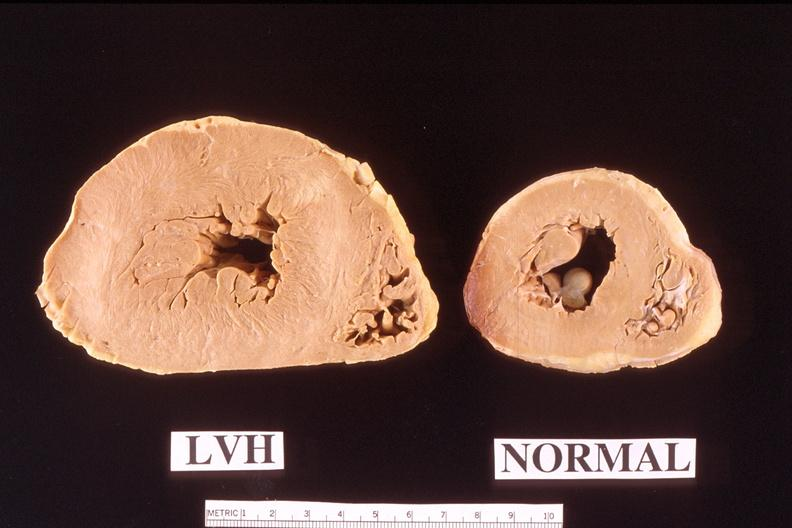what left ventricular hypertrophy compared to normal heart?
Answer the question using a single word or phrase. Heart 